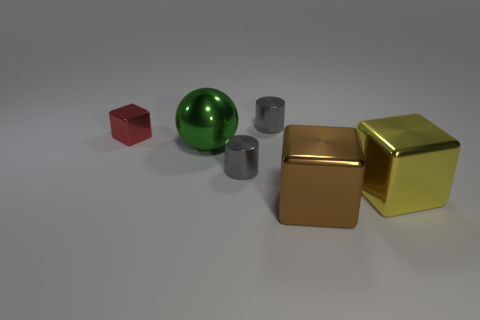What number of objects are either shiny cubes that are on the left side of the brown thing or big objects that are behind the yellow metal thing?
Your answer should be compact. 2. The tiny thing that is the same shape as the large yellow shiny object is what color?
Give a very brief answer. Red. What is the shape of the metallic thing that is behind the green object and to the right of the red metallic cube?
Ensure brevity in your answer.  Cylinder. Is the number of large green metal things greater than the number of blocks?
Provide a succinct answer. No. The brown thing that is the same shape as the tiny red thing is what size?
Provide a short and direct response. Large. Are there any green things that are left of the big green metal sphere that is to the left of the big yellow thing?
Your answer should be very brief. No. What number of other things are the same shape as the red object?
Keep it short and to the point. 2. Is the number of cylinders behind the green metallic thing greater than the number of green shiny objects that are to the right of the large yellow thing?
Offer a very short reply. Yes. Does the object to the right of the brown metallic cube have the same size as the brown metal thing in front of the red block?
Your response must be concise. Yes. What is the shape of the big green metallic thing?
Keep it short and to the point. Sphere. 